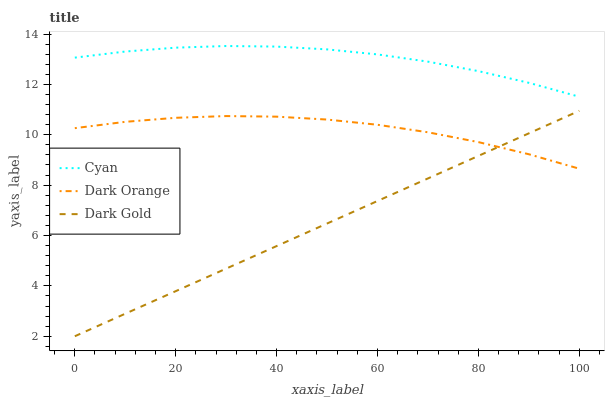Does Dark Gold have the minimum area under the curve?
Answer yes or no. Yes. Does Cyan have the maximum area under the curve?
Answer yes or no. Yes. Does Dark Orange have the minimum area under the curve?
Answer yes or no. No. Does Dark Orange have the maximum area under the curve?
Answer yes or no. No. Is Dark Gold the smoothest?
Answer yes or no. Yes. Is Dark Orange the roughest?
Answer yes or no. Yes. Is Dark Orange the smoothest?
Answer yes or no. No. Is Dark Gold the roughest?
Answer yes or no. No. Does Dark Gold have the lowest value?
Answer yes or no. Yes. Does Dark Orange have the lowest value?
Answer yes or no. No. Does Cyan have the highest value?
Answer yes or no. Yes. Does Dark Gold have the highest value?
Answer yes or no. No. Is Dark Orange less than Cyan?
Answer yes or no. Yes. Is Cyan greater than Dark Gold?
Answer yes or no. Yes. Does Dark Orange intersect Dark Gold?
Answer yes or no. Yes. Is Dark Orange less than Dark Gold?
Answer yes or no. No. Is Dark Orange greater than Dark Gold?
Answer yes or no. No. Does Dark Orange intersect Cyan?
Answer yes or no. No. 